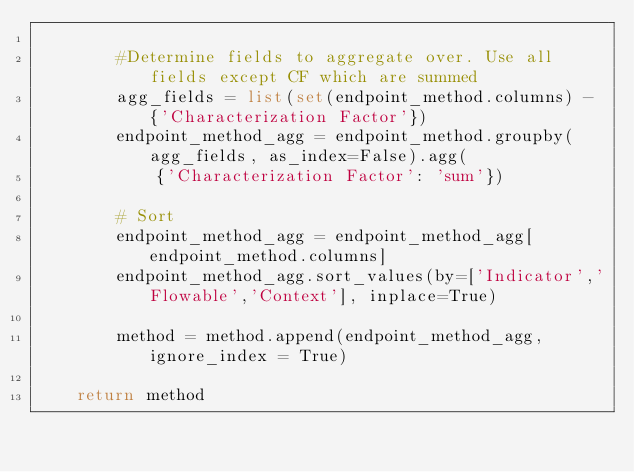Convert code to text. <code><loc_0><loc_0><loc_500><loc_500><_Python_>
        #Determine fields to aggregate over. Use all fields except CF which are summed
        agg_fields = list(set(endpoint_method.columns) - {'Characterization Factor'})
        endpoint_method_agg = endpoint_method.groupby(agg_fields, as_index=False).agg(
            {'Characterization Factor': 'sum'})
        
        # Sort
        endpoint_method_agg = endpoint_method_agg[endpoint_method.columns]
        endpoint_method_agg.sort_values(by=['Indicator','Flowable','Context'], inplace=True)
        
        method = method.append(endpoint_method_agg, ignore_index = True)
    
    return method
</code> 